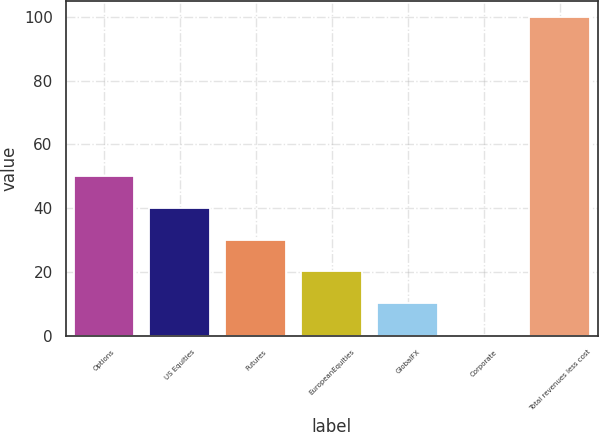Convert chart. <chart><loc_0><loc_0><loc_500><loc_500><bar_chart><fcel>Options<fcel>US Equities<fcel>Futures<fcel>EuropeanEquities<fcel>GlobalFX<fcel>Corporate<fcel>Total revenues less cost<nl><fcel>50.2<fcel>40.1<fcel>30.12<fcel>20.14<fcel>10.16<fcel>0.18<fcel>100<nl></chart> 